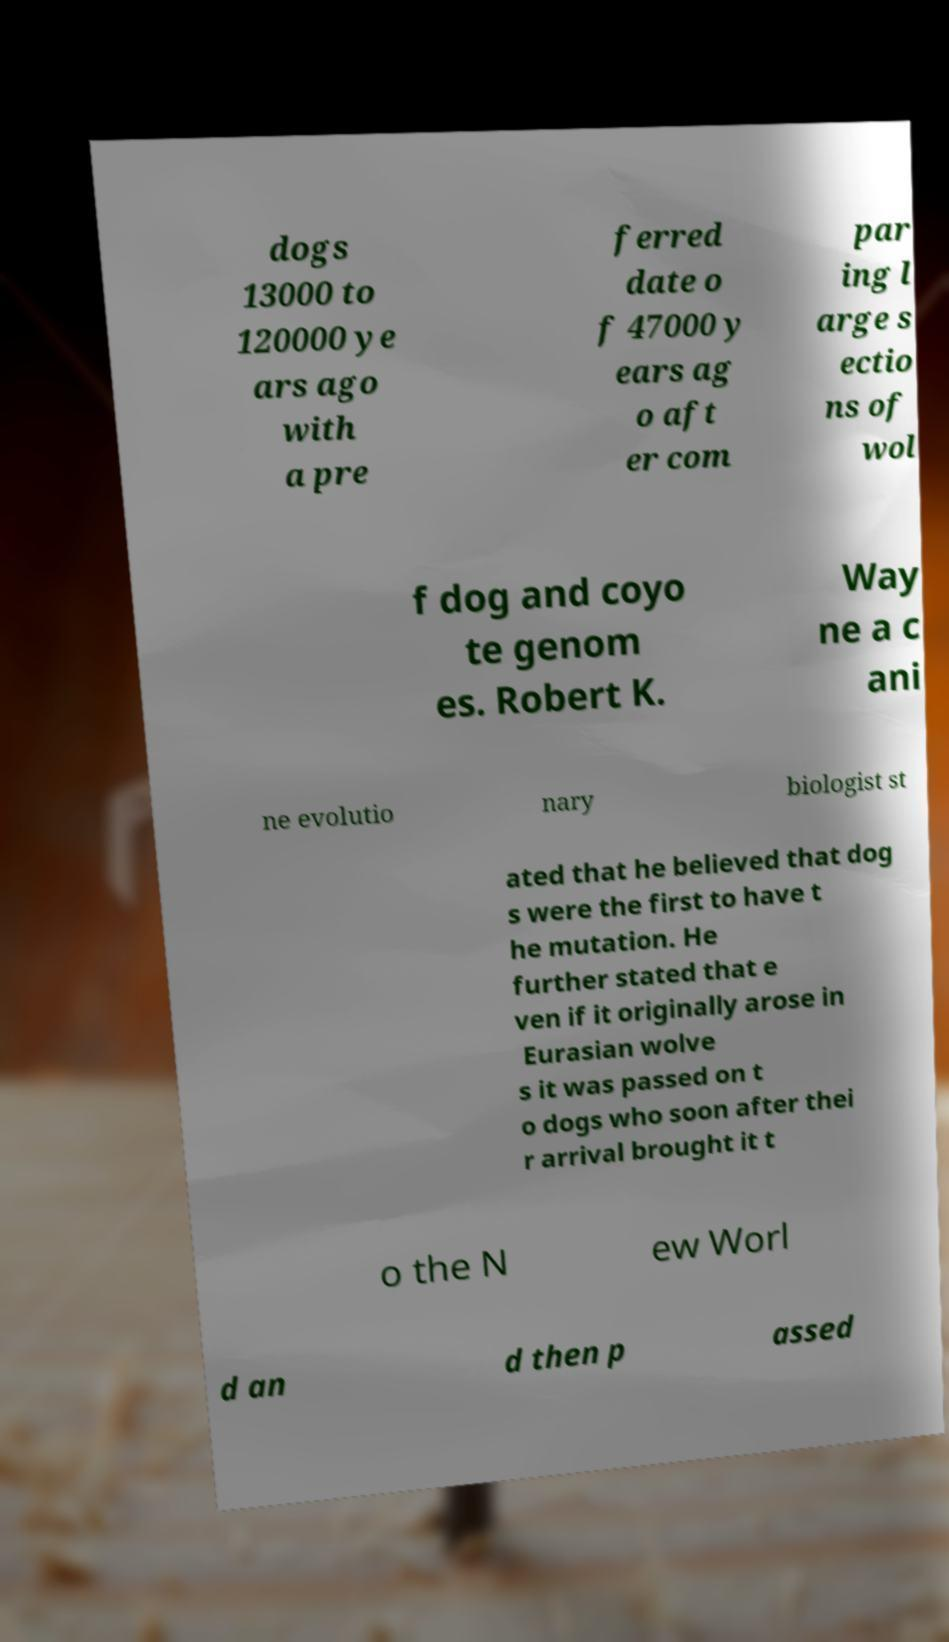There's text embedded in this image that I need extracted. Can you transcribe it verbatim? dogs 13000 to 120000 ye ars ago with a pre ferred date o f 47000 y ears ag o aft er com par ing l arge s ectio ns of wol f dog and coyo te genom es. Robert K. Way ne a c ani ne evolutio nary biologist st ated that he believed that dog s were the first to have t he mutation. He further stated that e ven if it originally arose in Eurasian wolve s it was passed on t o dogs who soon after thei r arrival brought it t o the N ew Worl d an d then p assed 